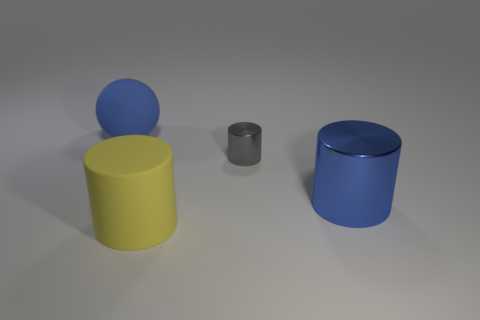Are there any other things that have the same size as the gray metal thing?
Your answer should be compact. No. What number of other things are there of the same shape as the small shiny thing?
Provide a short and direct response. 2. Is the large yellow thing the same shape as the small gray shiny thing?
Your response must be concise. Yes. How many objects are either cylinders in front of the gray metallic cylinder or big blue things that are on the left side of the gray cylinder?
Give a very brief answer. 3. What number of objects are small gray metallic things or large yellow objects?
Offer a very short reply. 2. There is a blue object that is in front of the blue rubber sphere; how many yellow matte objects are left of it?
Offer a terse response. 1. How many other things are there of the same size as the yellow matte object?
Your answer should be very brief. 2. Is the shape of the shiny thing that is to the right of the tiny thing the same as  the big yellow thing?
Your answer should be very brief. Yes. What is the material of the blue thing that is in front of the tiny shiny object?
Offer a very short reply. Metal. There is a large metal thing that is the same color as the large ball; what is its shape?
Give a very brief answer. Cylinder. 